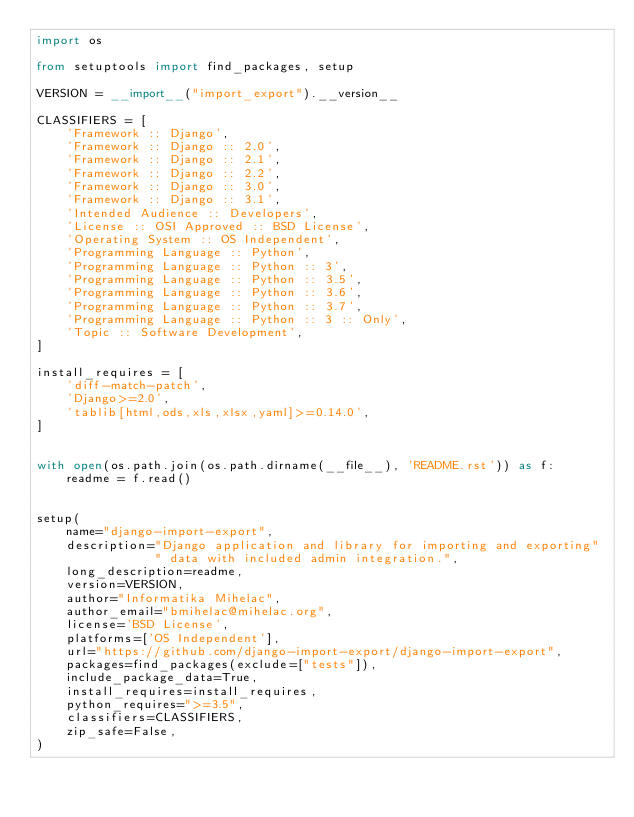<code> <loc_0><loc_0><loc_500><loc_500><_Python_>import os

from setuptools import find_packages, setup

VERSION = __import__("import_export").__version__

CLASSIFIERS = [
    'Framework :: Django',
    'Framework :: Django :: 2.0',
    'Framework :: Django :: 2.1',
    'Framework :: Django :: 2.2',
    'Framework :: Django :: 3.0',
    'Framework :: Django :: 3.1',
    'Intended Audience :: Developers',
    'License :: OSI Approved :: BSD License',
    'Operating System :: OS Independent',
    'Programming Language :: Python',
    'Programming Language :: Python :: 3',
    'Programming Language :: Python :: 3.5',
    'Programming Language :: Python :: 3.6',
    'Programming Language :: Python :: 3.7',
    'Programming Language :: Python :: 3 :: Only',
    'Topic :: Software Development',
]

install_requires = [
    'diff-match-patch',
    'Django>=2.0',
    'tablib[html,ods,xls,xlsx,yaml]>=0.14.0',
]


with open(os.path.join(os.path.dirname(__file__), 'README.rst')) as f:
    readme = f.read()


setup(
    name="django-import-export",
    description="Django application and library for importing and exporting"
                " data with included admin integration.",
    long_description=readme,
    version=VERSION,
    author="Informatika Mihelac",
    author_email="bmihelac@mihelac.org",
    license='BSD License',
    platforms=['OS Independent'],
    url="https://github.com/django-import-export/django-import-export",
    packages=find_packages(exclude=["tests"]),
    include_package_data=True,
    install_requires=install_requires,
    python_requires=">=3.5",
    classifiers=CLASSIFIERS,
    zip_safe=False,
)
</code> 